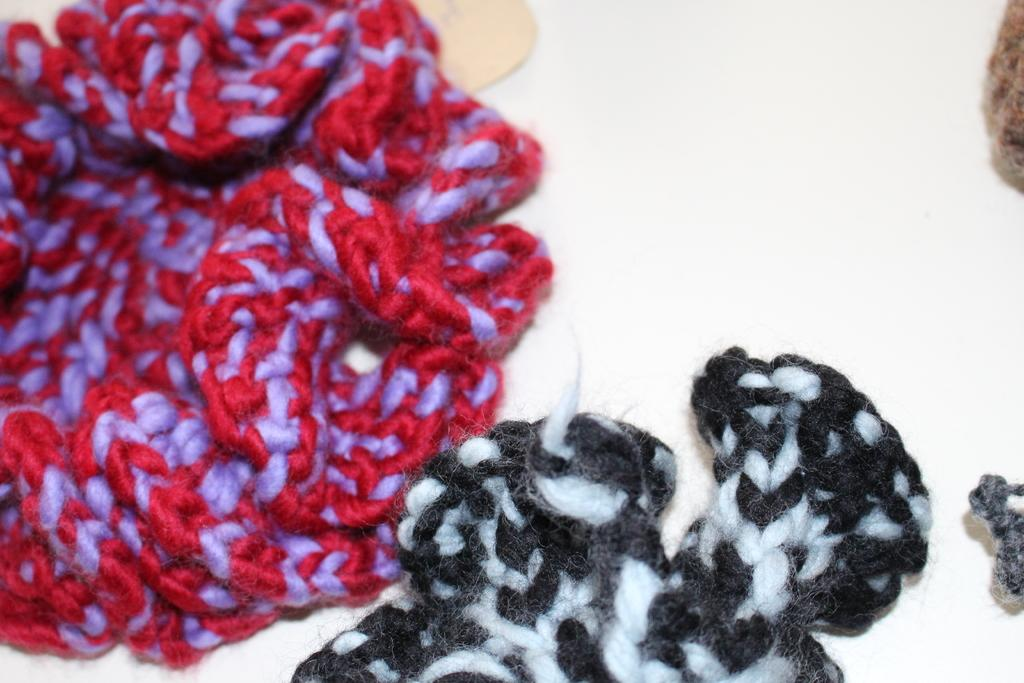What is the color of the surface in the image? The surface in the image is white. What can be seen on the white surface? There are threads on the surface. What colors do the threads have? The threads have various colors, including red, violet, black, white, and brown. How many beggars are visible in the image? There are no beggars present in the image; it features a white surface with threads of various colors. 